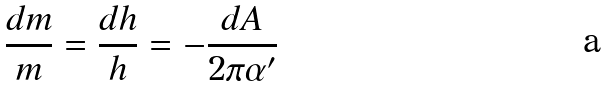Convert formula to latex. <formula><loc_0><loc_0><loc_500><loc_500>\frac { d m } { m } = \frac { d h } { h } = - \frac { d A } { 2 \pi \alpha ^ { \prime } }</formula> 